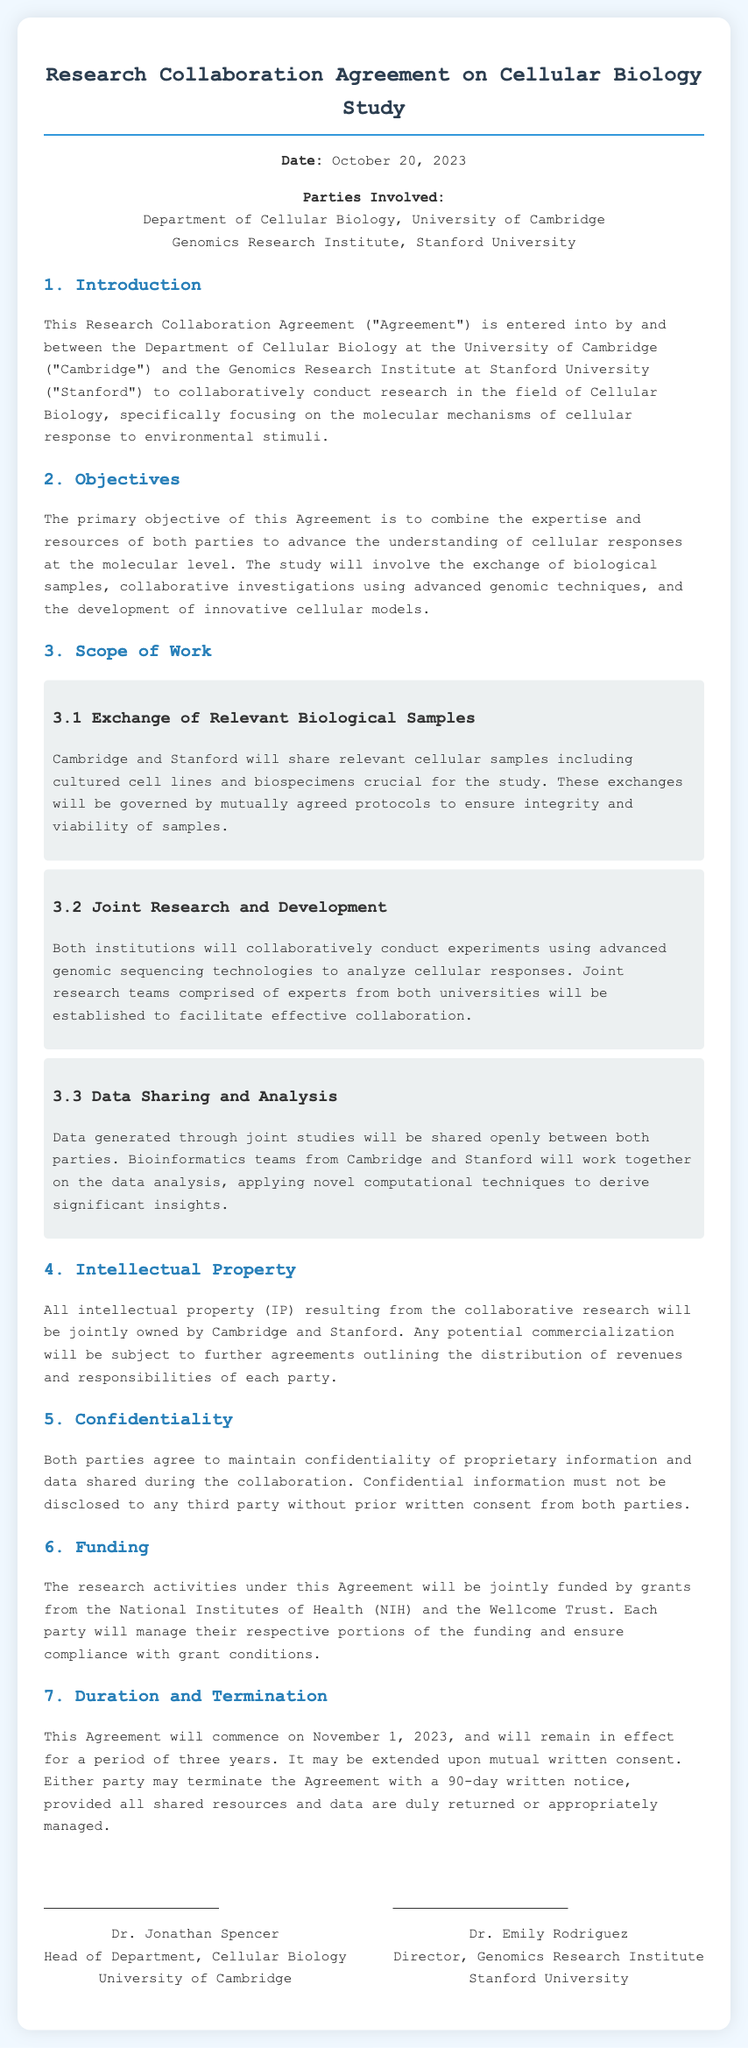What is the date of the agreement? The date mentioned at the beginning of the agreement is a specific date referencing when the parties entered into the agreement.
Answer: October 20, 2023 Who are the parties involved in the agreement? The parties involved are listed under "Parties Involved," which include two academic institutions.
Answer: Department of Cellular Biology, University of Cambridge and Genomics Research Institute, Stanford University What is the primary objective of the agreement? The primary objective is clearly stated in the "Objectives" section, focusing on the goal of the collaboration.
Answer: To advance the understanding of cellular responses at the molecular level How long will the agreement be in effect? The duration of the agreement is specified in the "Duration and Termination" section, indicating the length of time it will last.
Answer: Three years Who retains ownership of the intellectual property resulting from the study? The section on intellectual property outlines the ownership details related to the research outputs of the collaboration.
Answer: Jointly owned by Cambridge and Stanford What type of funding supports the research activities? The funding sources for the research activities are identified in the "Funding" section, specifying the organizations providing financial support.
Answer: National Institutes of Health (NIH) and the Wellcome Trust How can either party terminate the agreement? The procedure for termination is dictated in the "Duration and Termination" section, with a specific notice period mentioned.
Answer: 90-day written notice What are the responsibilities of the bioinformatics teams? The responsibility of the bioinformatics teams is outlined in the "Data Sharing and Analysis" section, which details their role in the collaborative effort.
Answer: Work together on the data analysis What must be maintained regarding proprietary information? The confidentiality obligations are emphasized in the "Confidentiality" section, indicating what must be preserved during the collaboration.
Answer: Confidentiality of proprietary information 